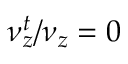<formula> <loc_0><loc_0><loc_500><loc_500>\nu _ { z } ^ { t } / \nu _ { z } = 0</formula> 